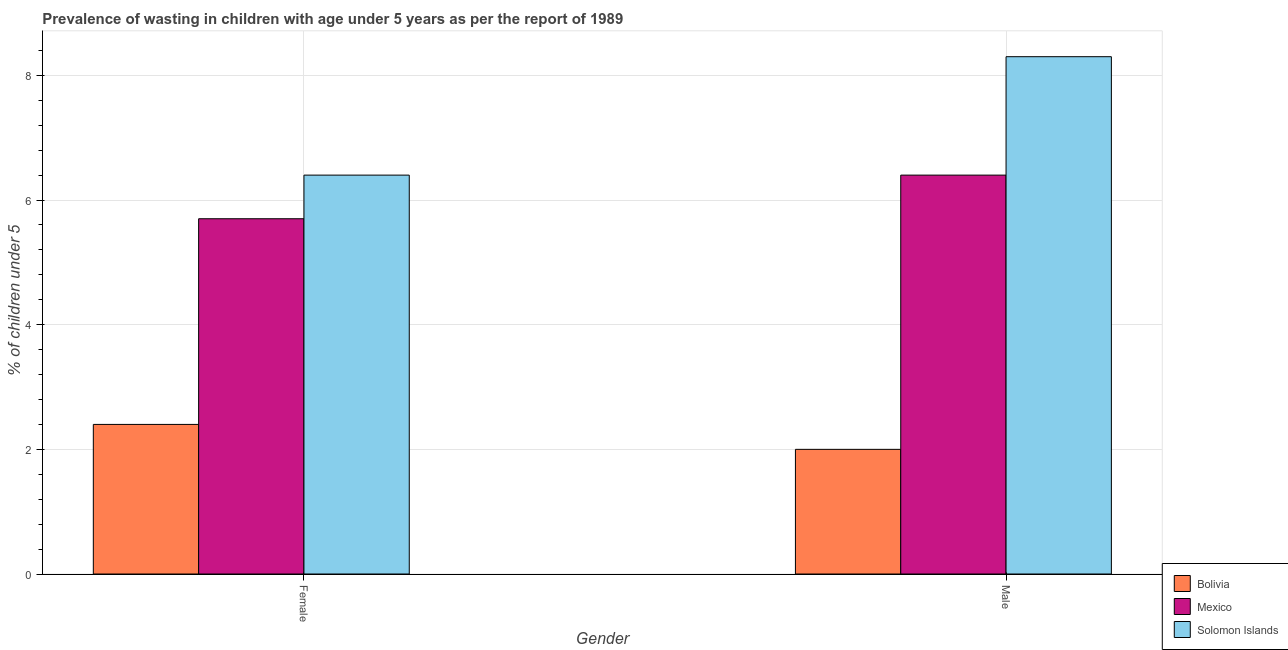How many different coloured bars are there?
Your response must be concise. 3. How many groups of bars are there?
Make the answer very short. 2. Are the number of bars on each tick of the X-axis equal?
Your answer should be very brief. Yes. Across all countries, what is the maximum percentage of undernourished female children?
Your answer should be compact. 6.4. Across all countries, what is the minimum percentage of undernourished male children?
Your answer should be compact. 2. In which country was the percentage of undernourished male children maximum?
Give a very brief answer. Solomon Islands. In which country was the percentage of undernourished female children minimum?
Ensure brevity in your answer.  Bolivia. What is the total percentage of undernourished female children in the graph?
Offer a very short reply. 14.5. What is the difference between the percentage of undernourished female children in Solomon Islands and that in Mexico?
Your answer should be compact. 0.7. What is the average percentage of undernourished male children per country?
Offer a very short reply. 5.57. What is the difference between the percentage of undernourished male children and percentage of undernourished female children in Mexico?
Keep it short and to the point. 0.7. What is the ratio of the percentage of undernourished female children in Mexico to that in Solomon Islands?
Your answer should be compact. 0.89. In how many countries, is the percentage of undernourished female children greater than the average percentage of undernourished female children taken over all countries?
Provide a succinct answer. 2. What does the 3rd bar from the left in Female represents?
Your response must be concise. Solomon Islands. Are all the bars in the graph horizontal?
Ensure brevity in your answer.  No. Are the values on the major ticks of Y-axis written in scientific E-notation?
Ensure brevity in your answer.  No. Does the graph contain any zero values?
Make the answer very short. No. Does the graph contain grids?
Make the answer very short. Yes. Where does the legend appear in the graph?
Your answer should be compact. Bottom right. How many legend labels are there?
Ensure brevity in your answer.  3. How are the legend labels stacked?
Offer a very short reply. Vertical. What is the title of the graph?
Provide a short and direct response. Prevalence of wasting in children with age under 5 years as per the report of 1989. Does "Israel" appear as one of the legend labels in the graph?
Your answer should be compact. No. What is the label or title of the X-axis?
Offer a terse response. Gender. What is the label or title of the Y-axis?
Keep it short and to the point.  % of children under 5. What is the  % of children under 5 of Bolivia in Female?
Provide a succinct answer. 2.4. What is the  % of children under 5 of Mexico in Female?
Your response must be concise. 5.7. What is the  % of children under 5 in Solomon Islands in Female?
Keep it short and to the point. 6.4. What is the  % of children under 5 of Bolivia in Male?
Offer a very short reply. 2. What is the  % of children under 5 in Mexico in Male?
Provide a succinct answer. 6.4. What is the  % of children under 5 in Solomon Islands in Male?
Make the answer very short. 8.3. Across all Gender, what is the maximum  % of children under 5 of Bolivia?
Ensure brevity in your answer.  2.4. Across all Gender, what is the maximum  % of children under 5 in Mexico?
Offer a terse response. 6.4. Across all Gender, what is the maximum  % of children under 5 in Solomon Islands?
Your answer should be very brief. 8.3. Across all Gender, what is the minimum  % of children under 5 of Mexico?
Provide a short and direct response. 5.7. Across all Gender, what is the minimum  % of children under 5 of Solomon Islands?
Your answer should be very brief. 6.4. What is the total  % of children under 5 of Bolivia in the graph?
Ensure brevity in your answer.  4.4. What is the difference between the  % of children under 5 in Bolivia in Female and that in Male?
Provide a short and direct response. 0.4. What is the difference between the  % of children under 5 in Solomon Islands in Female and that in Male?
Provide a succinct answer. -1.9. What is the difference between the  % of children under 5 in Bolivia in Female and the  % of children under 5 in Mexico in Male?
Provide a succinct answer. -4. What is the difference between the  % of children under 5 in Mexico in Female and the  % of children under 5 in Solomon Islands in Male?
Make the answer very short. -2.6. What is the average  % of children under 5 of Bolivia per Gender?
Give a very brief answer. 2.2. What is the average  % of children under 5 in Mexico per Gender?
Offer a very short reply. 6.05. What is the average  % of children under 5 of Solomon Islands per Gender?
Offer a very short reply. 7.35. What is the difference between the  % of children under 5 of Bolivia and  % of children under 5 of Solomon Islands in Female?
Your response must be concise. -4. What is the difference between the  % of children under 5 in Mexico and  % of children under 5 in Solomon Islands in Female?
Offer a very short reply. -0.7. What is the difference between the  % of children under 5 of Bolivia and  % of children under 5 of Mexico in Male?
Offer a terse response. -4.4. What is the difference between the  % of children under 5 in Bolivia and  % of children under 5 in Solomon Islands in Male?
Offer a terse response. -6.3. What is the ratio of the  % of children under 5 in Mexico in Female to that in Male?
Make the answer very short. 0.89. What is the ratio of the  % of children under 5 of Solomon Islands in Female to that in Male?
Provide a succinct answer. 0.77. What is the difference between the highest and the second highest  % of children under 5 in Bolivia?
Provide a succinct answer. 0.4. 